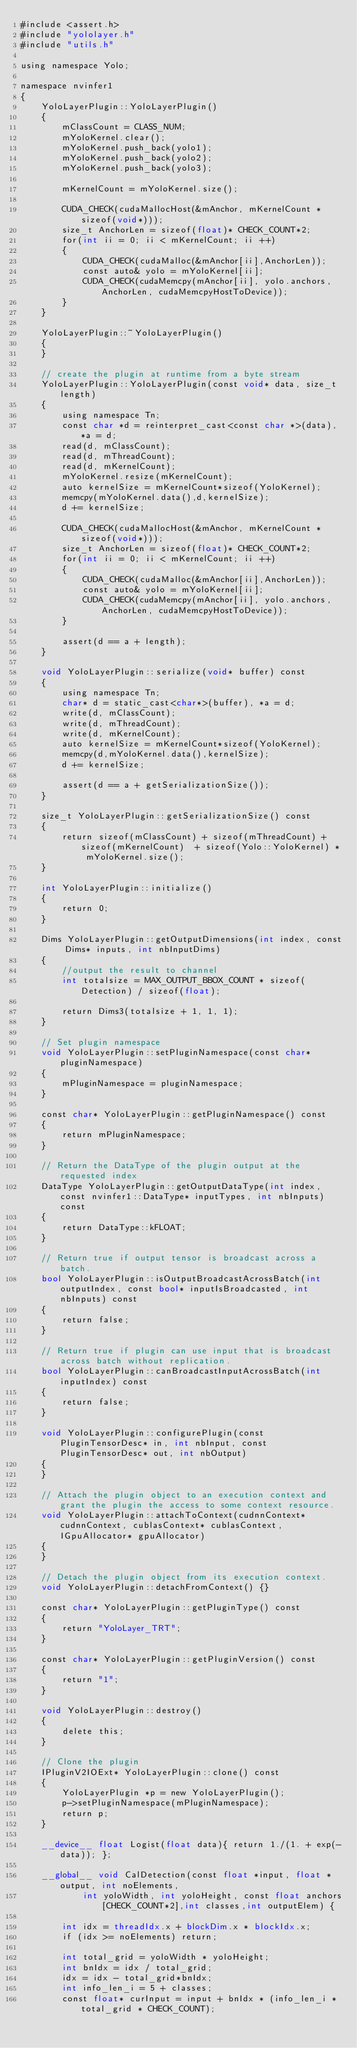<code> <loc_0><loc_0><loc_500><loc_500><_Cuda_>#include <assert.h>
#include "yololayer.h"
#include "utils.h"

using namespace Yolo;

namespace nvinfer1
{
    YoloLayerPlugin::YoloLayerPlugin()
    {
        mClassCount = CLASS_NUM;
        mYoloKernel.clear();
        mYoloKernel.push_back(yolo1);
        mYoloKernel.push_back(yolo2);
        mYoloKernel.push_back(yolo3);

        mKernelCount = mYoloKernel.size();

        CUDA_CHECK(cudaMallocHost(&mAnchor, mKernelCount * sizeof(void*)));
        size_t AnchorLen = sizeof(float)* CHECK_COUNT*2;
        for(int ii = 0; ii < mKernelCount; ii ++)
        {
            CUDA_CHECK(cudaMalloc(&mAnchor[ii],AnchorLen));
            const auto& yolo = mYoloKernel[ii];
            CUDA_CHECK(cudaMemcpy(mAnchor[ii], yolo.anchors, AnchorLen, cudaMemcpyHostToDevice));
        }
    }

    YoloLayerPlugin::~YoloLayerPlugin()
    {
    }

    // create the plugin at runtime from a byte stream
    YoloLayerPlugin::YoloLayerPlugin(const void* data, size_t length)
    {
        using namespace Tn;
        const char *d = reinterpret_cast<const char *>(data), *a = d;
        read(d, mClassCount);
        read(d, mThreadCount);
        read(d, mKernelCount);
        mYoloKernel.resize(mKernelCount);
        auto kernelSize = mKernelCount*sizeof(YoloKernel);
        memcpy(mYoloKernel.data(),d,kernelSize);
        d += kernelSize;

        CUDA_CHECK(cudaMallocHost(&mAnchor, mKernelCount * sizeof(void*)));
        size_t AnchorLen = sizeof(float)* CHECK_COUNT*2;
        for(int ii = 0; ii < mKernelCount; ii ++)
        {
            CUDA_CHECK(cudaMalloc(&mAnchor[ii],AnchorLen));
            const auto& yolo = mYoloKernel[ii];
            CUDA_CHECK(cudaMemcpy(mAnchor[ii], yolo.anchors, AnchorLen, cudaMemcpyHostToDevice));
        }

        assert(d == a + length);
    }

    void YoloLayerPlugin::serialize(void* buffer) const
    {
        using namespace Tn;
        char* d = static_cast<char*>(buffer), *a = d;
        write(d, mClassCount);
        write(d, mThreadCount);
        write(d, mKernelCount);
        auto kernelSize = mKernelCount*sizeof(YoloKernel);
        memcpy(d,mYoloKernel.data(),kernelSize);
        d += kernelSize;

        assert(d == a + getSerializationSize());
    }
    
    size_t YoloLayerPlugin::getSerializationSize() const
    {  
        return sizeof(mClassCount) + sizeof(mThreadCount) + sizeof(mKernelCount)  + sizeof(Yolo::YoloKernel) * mYoloKernel.size();
    }

    int YoloLayerPlugin::initialize()
    { 
        return 0;
    }
    
    Dims YoloLayerPlugin::getOutputDimensions(int index, const Dims* inputs, int nbInputDims)
    {
        //output the result to channel
        int totalsize = MAX_OUTPUT_BBOX_COUNT * sizeof(Detection) / sizeof(float);

        return Dims3(totalsize + 1, 1, 1);
    }

    // Set plugin namespace
    void YoloLayerPlugin::setPluginNamespace(const char* pluginNamespace)
    {
        mPluginNamespace = pluginNamespace;
    }

    const char* YoloLayerPlugin::getPluginNamespace() const
    {
        return mPluginNamespace;
    }

    // Return the DataType of the plugin output at the requested index
    DataType YoloLayerPlugin::getOutputDataType(int index, const nvinfer1::DataType* inputTypes, int nbInputs) const
    {
        return DataType::kFLOAT;
    }

    // Return true if output tensor is broadcast across a batch.
    bool YoloLayerPlugin::isOutputBroadcastAcrossBatch(int outputIndex, const bool* inputIsBroadcasted, int nbInputs) const
    {
        return false;
    }

    // Return true if plugin can use input that is broadcast across batch without replication.
    bool YoloLayerPlugin::canBroadcastInputAcrossBatch(int inputIndex) const
    {
        return false;
    }

    void YoloLayerPlugin::configurePlugin(const PluginTensorDesc* in, int nbInput, const PluginTensorDesc* out, int nbOutput)
    {
    }

    // Attach the plugin object to an execution context and grant the plugin the access to some context resource.
    void YoloLayerPlugin::attachToContext(cudnnContext* cudnnContext, cublasContext* cublasContext, IGpuAllocator* gpuAllocator)
    {
    }

    // Detach the plugin object from its execution context.
    void YoloLayerPlugin::detachFromContext() {}

    const char* YoloLayerPlugin::getPluginType() const
    {
        return "YoloLayer_TRT";
    }

    const char* YoloLayerPlugin::getPluginVersion() const
    {
        return "1";
    }

    void YoloLayerPlugin::destroy()
    {
        delete this;
    }

    // Clone the plugin
    IPluginV2IOExt* YoloLayerPlugin::clone() const
    {
        YoloLayerPlugin *p = new YoloLayerPlugin();
        p->setPluginNamespace(mPluginNamespace);
        return p;
    }

    __device__ float Logist(float data){ return 1./(1. + exp(-data)); };

    __global__ void CalDetection(const float *input, float *output, int noElements, 
            int yoloWidth, int yoloHeight, const float anchors[CHECK_COUNT*2],int classes,int outputElem) {
 
        int idx = threadIdx.x + blockDim.x * blockIdx.x;
        if (idx >= noElements) return;

        int total_grid = yoloWidth * yoloHeight;
        int bnIdx = idx / total_grid;
        idx = idx - total_grid*bnIdx;
        int info_len_i = 5 + classes;
        const float* curInput = input + bnIdx * (info_len_i * total_grid * CHECK_COUNT);
</code> 